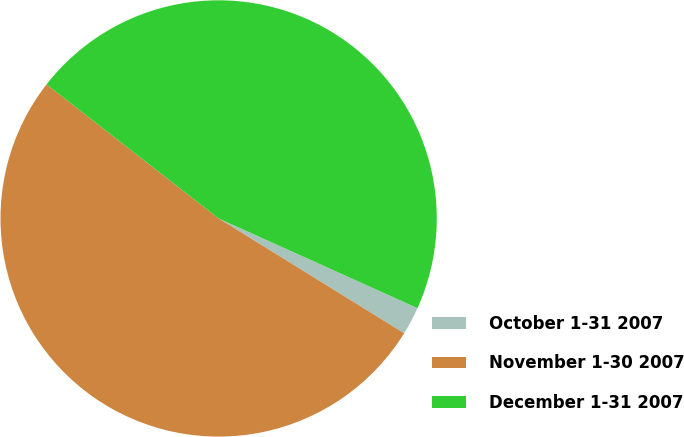Convert chart to OTSL. <chart><loc_0><loc_0><loc_500><loc_500><pie_chart><fcel>October 1-31 2007<fcel>November 1-30 2007<fcel>December 1-31 2007<nl><fcel>2.08%<fcel>51.71%<fcel>46.21%<nl></chart> 